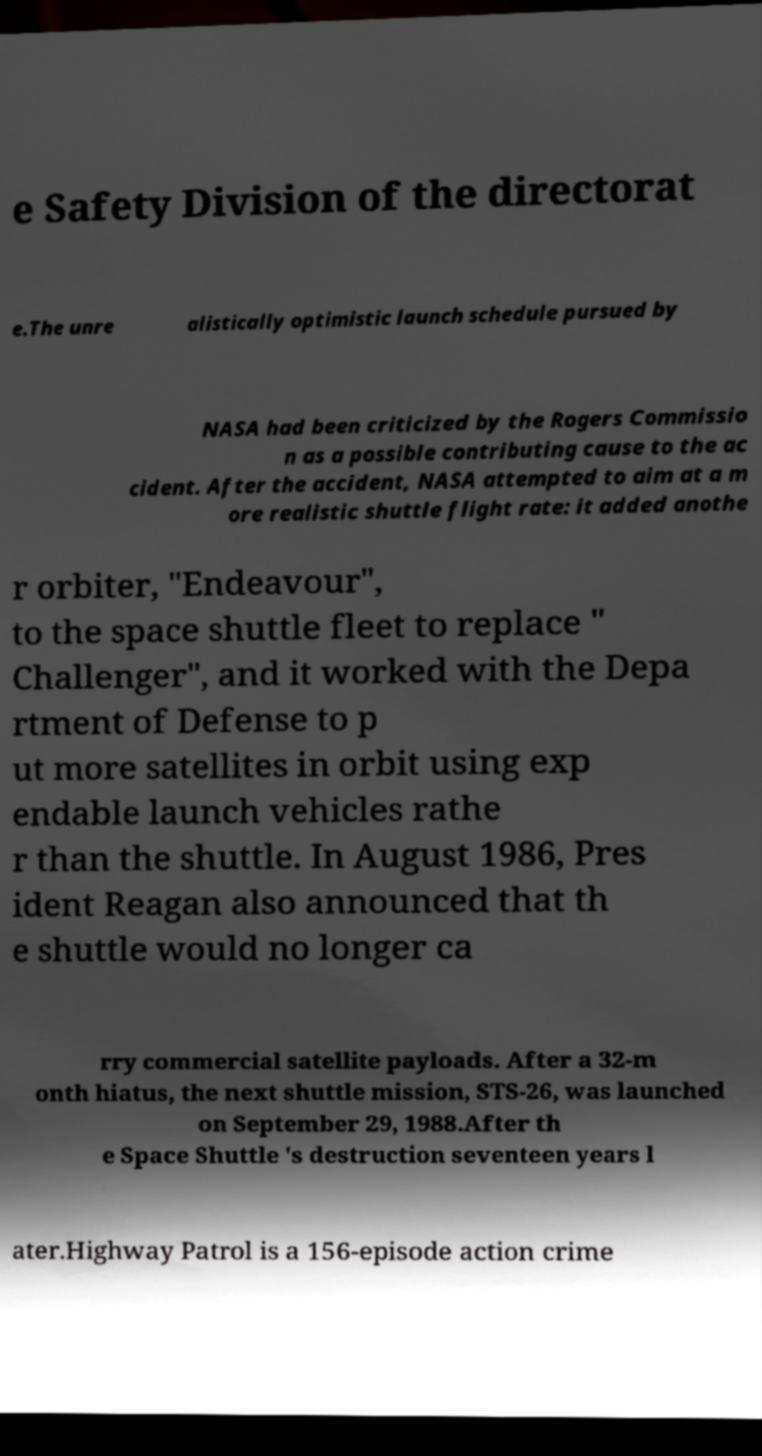Could you assist in decoding the text presented in this image and type it out clearly? e Safety Division of the directorat e.The unre alistically optimistic launch schedule pursued by NASA had been criticized by the Rogers Commissio n as a possible contributing cause to the ac cident. After the accident, NASA attempted to aim at a m ore realistic shuttle flight rate: it added anothe r orbiter, "Endeavour", to the space shuttle fleet to replace " Challenger", and it worked with the Depa rtment of Defense to p ut more satellites in orbit using exp endable launch vehicles rathe r than the shuttle. In August 1986, Pres ident Reagan also announced that th e shuttle would no longer ca rry commercial satellite payloads. After a 32-m onth hiatus, the next shuttle mission, STS-26, was launched on September 29, 1988.After th e Space Shuttle 's destruction seventeen years l ater.Highway Patrol is a 156-episode action crime 